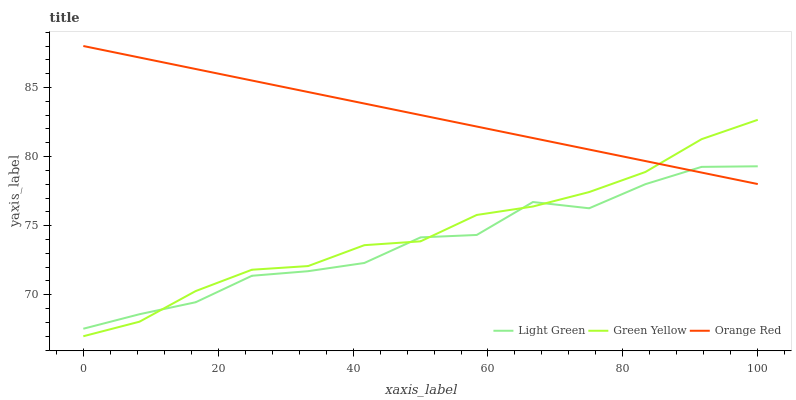Does Light Green have the minimum area under the curve?
Answer yes or no. Yes. Does Orange Red have the maximum area under the curve?
Answer yes or no. Yes. Does Orange Red have the minimum area under the curve?
Answer yes or no. No. Does Light Green have the maximum area under the curve?
Answer yes or no. No. Is Orange Red the smoothest?
Answer yes or no. Yes. Is Light Green the roughest?
Answer yes or no. Yes. Is Light Green the smoothest?
Answer yes or no. No. Is Orange Red the roughest?
Answer yes or no. No. Does Green Yellow have the lowest value?
Answer yes or no. Yes. Does Light Green have the lowest value?
Answer yes or no. No. Does Orange Red have the highest value?
Answer yes or no. Yes. Does Light Green have the highest value?
Answer yes or no. No. Does Light Green intersect Green Yellow?
Answer yes or no. Yes. Is Light Green less than Green Yellow?
Answer yes or no. No. Is Light Green greater than Green Yellow?
Answer yes or no. No. 